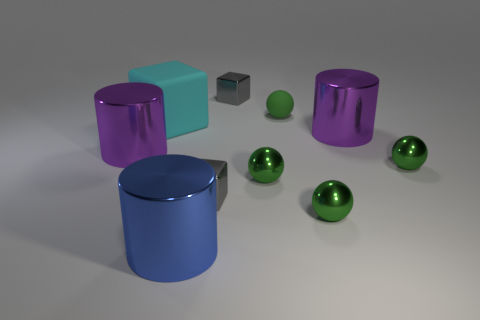Subtract all cubes. How many objects are left? 7 Add 4 large blue cylinders. How many large blue cylinders are left? 5 Add 7 large purple cylinders. How many large purple cylinders exist? 9 Subtract 0 purple spheres. How many objects are left? 10 Subtract all big blue things. Subtract all tiny gray metallic blocks. How many objects are left? 7 